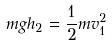<formula> <loc_0><loc_0><loc_500><loc_500>m g h _ { 2 } = \frac { 1 } { 2 } m v _ { 1 } ^ { 2 }</formula> 